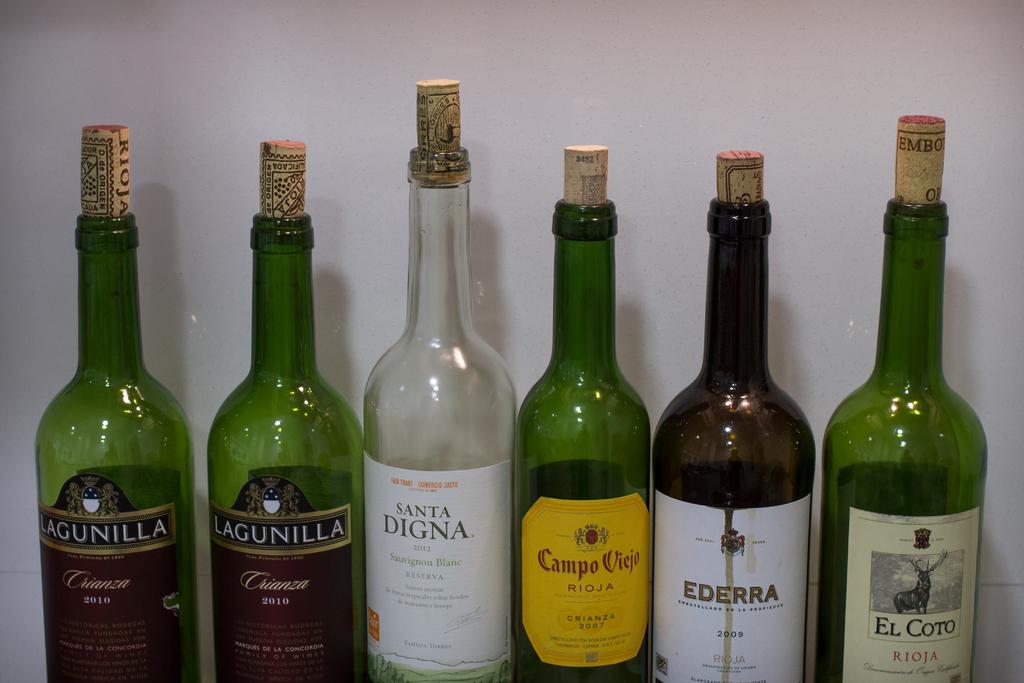What was campo viejo made?
Give a very brief answer. 2007. 